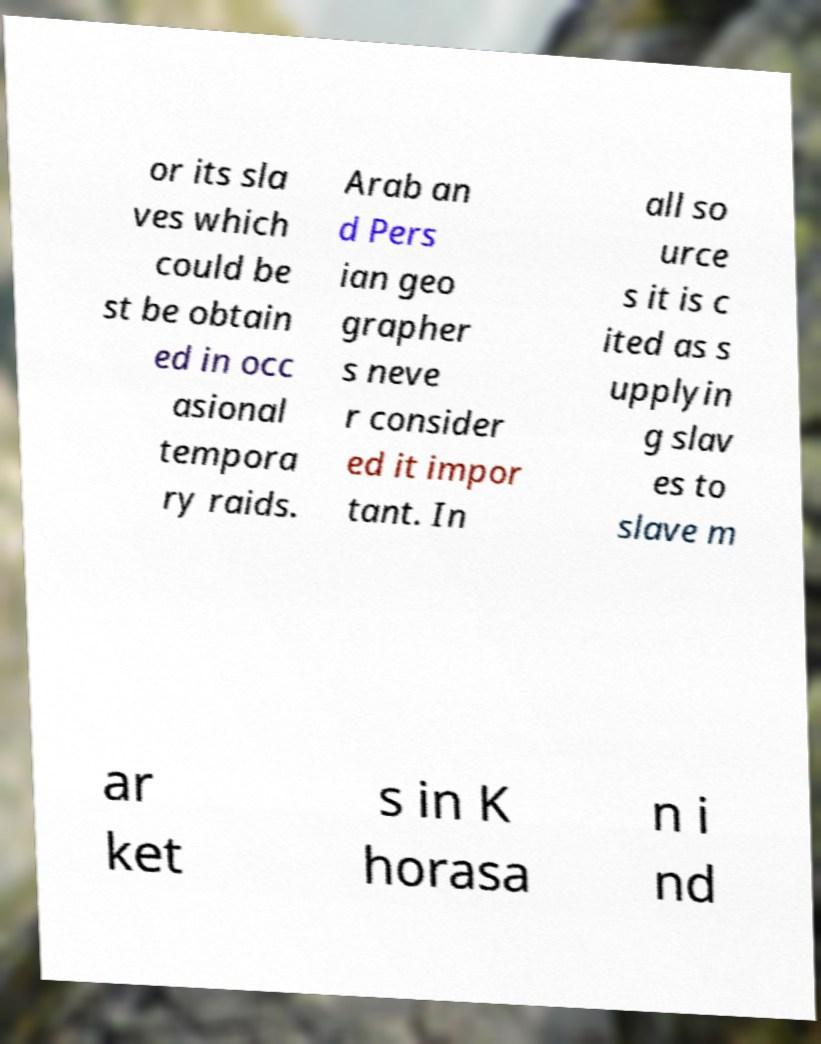There's text embedded in this image that I need extracted. Can you transcribe it verbatim? or its sla ves which could be st be obtain ed in occ asional tempora ry raids. Arab an d Pers ian geo grapher s neve r consider ed it impor tant. In all so urce s it is c ited as s upplyin g slav es to slave m ar ket s in K horasa n i nd 